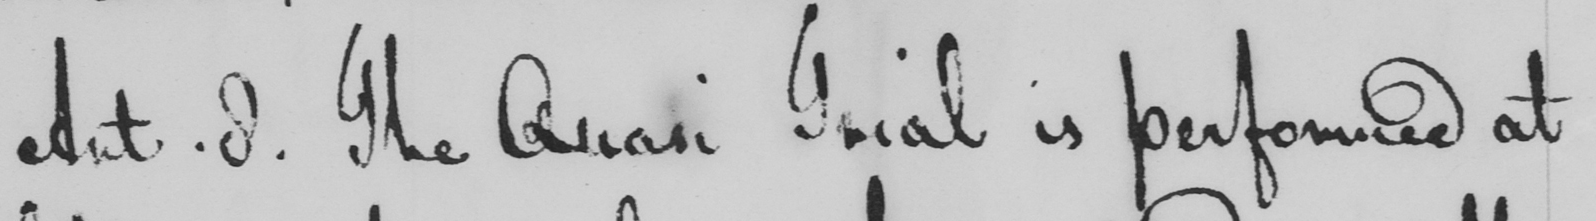Transcribe the text shown in this historical manuscript line. Art. 8. The Quasi Trial is performed at 